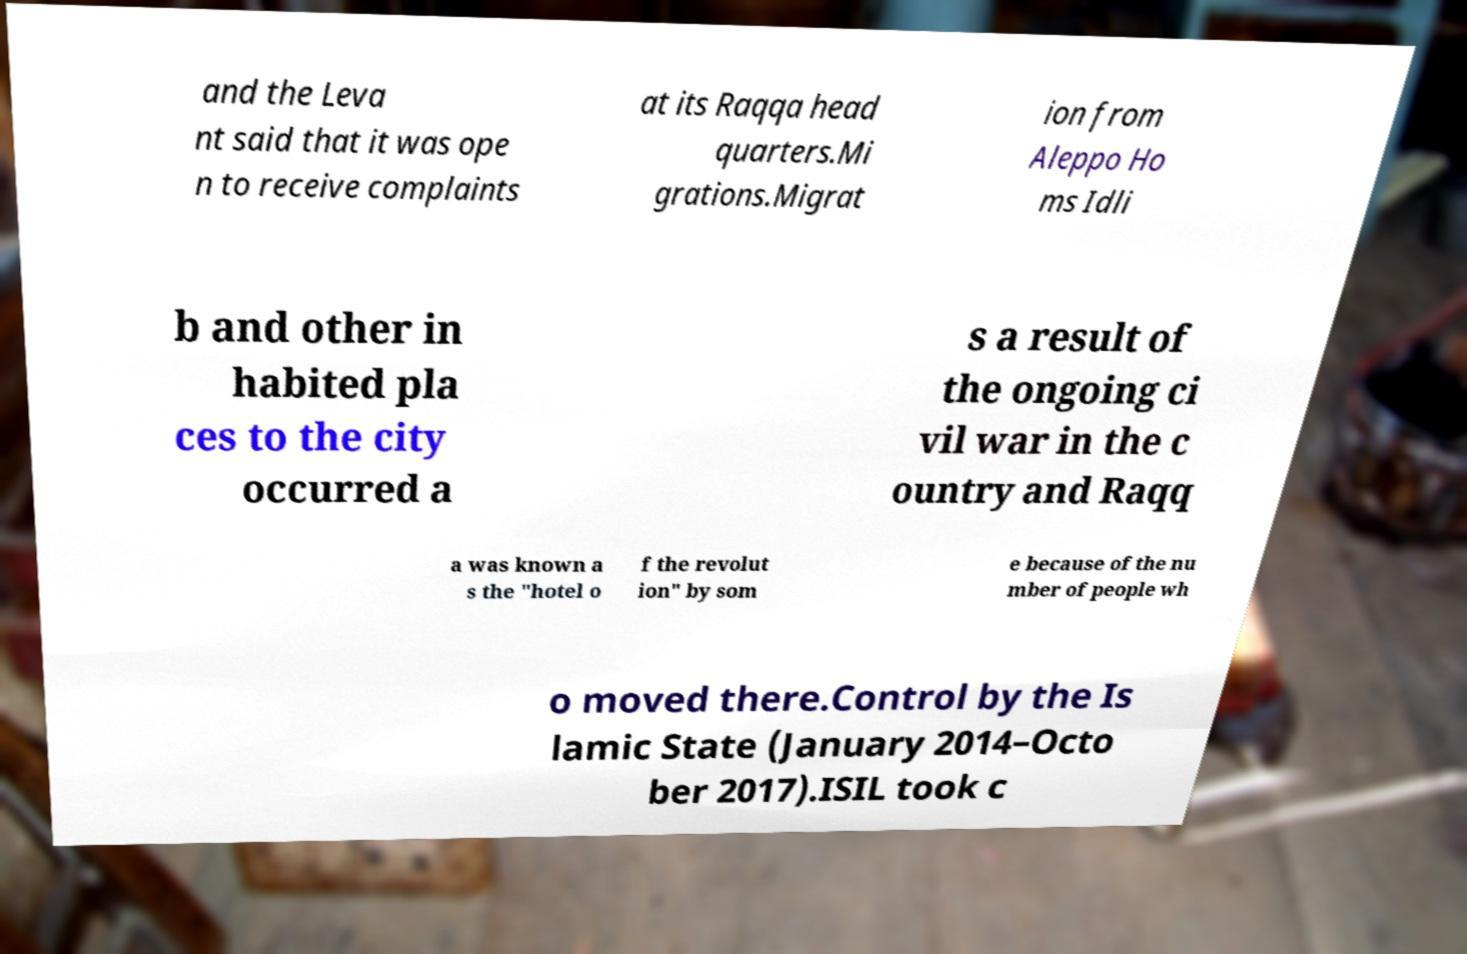What messages or text are displayed in this image? I need them in a readable, typed format. and the Leva nt said that it was ope n to receive complaints at its Raqqa head quarters.Mi grations.Migrat ion from Aleppo Ho ms Idli b and other in habited pla ces to the city occurred a s a result of the ongoing ci vil war in the c ountry and Raqq a was known a s the "hotel o f the revolut ion" by som e because of the nu mber of people wh o moved there.Control by the Is lamic State (January 2014–Octo ber 2017).ISIL took c 